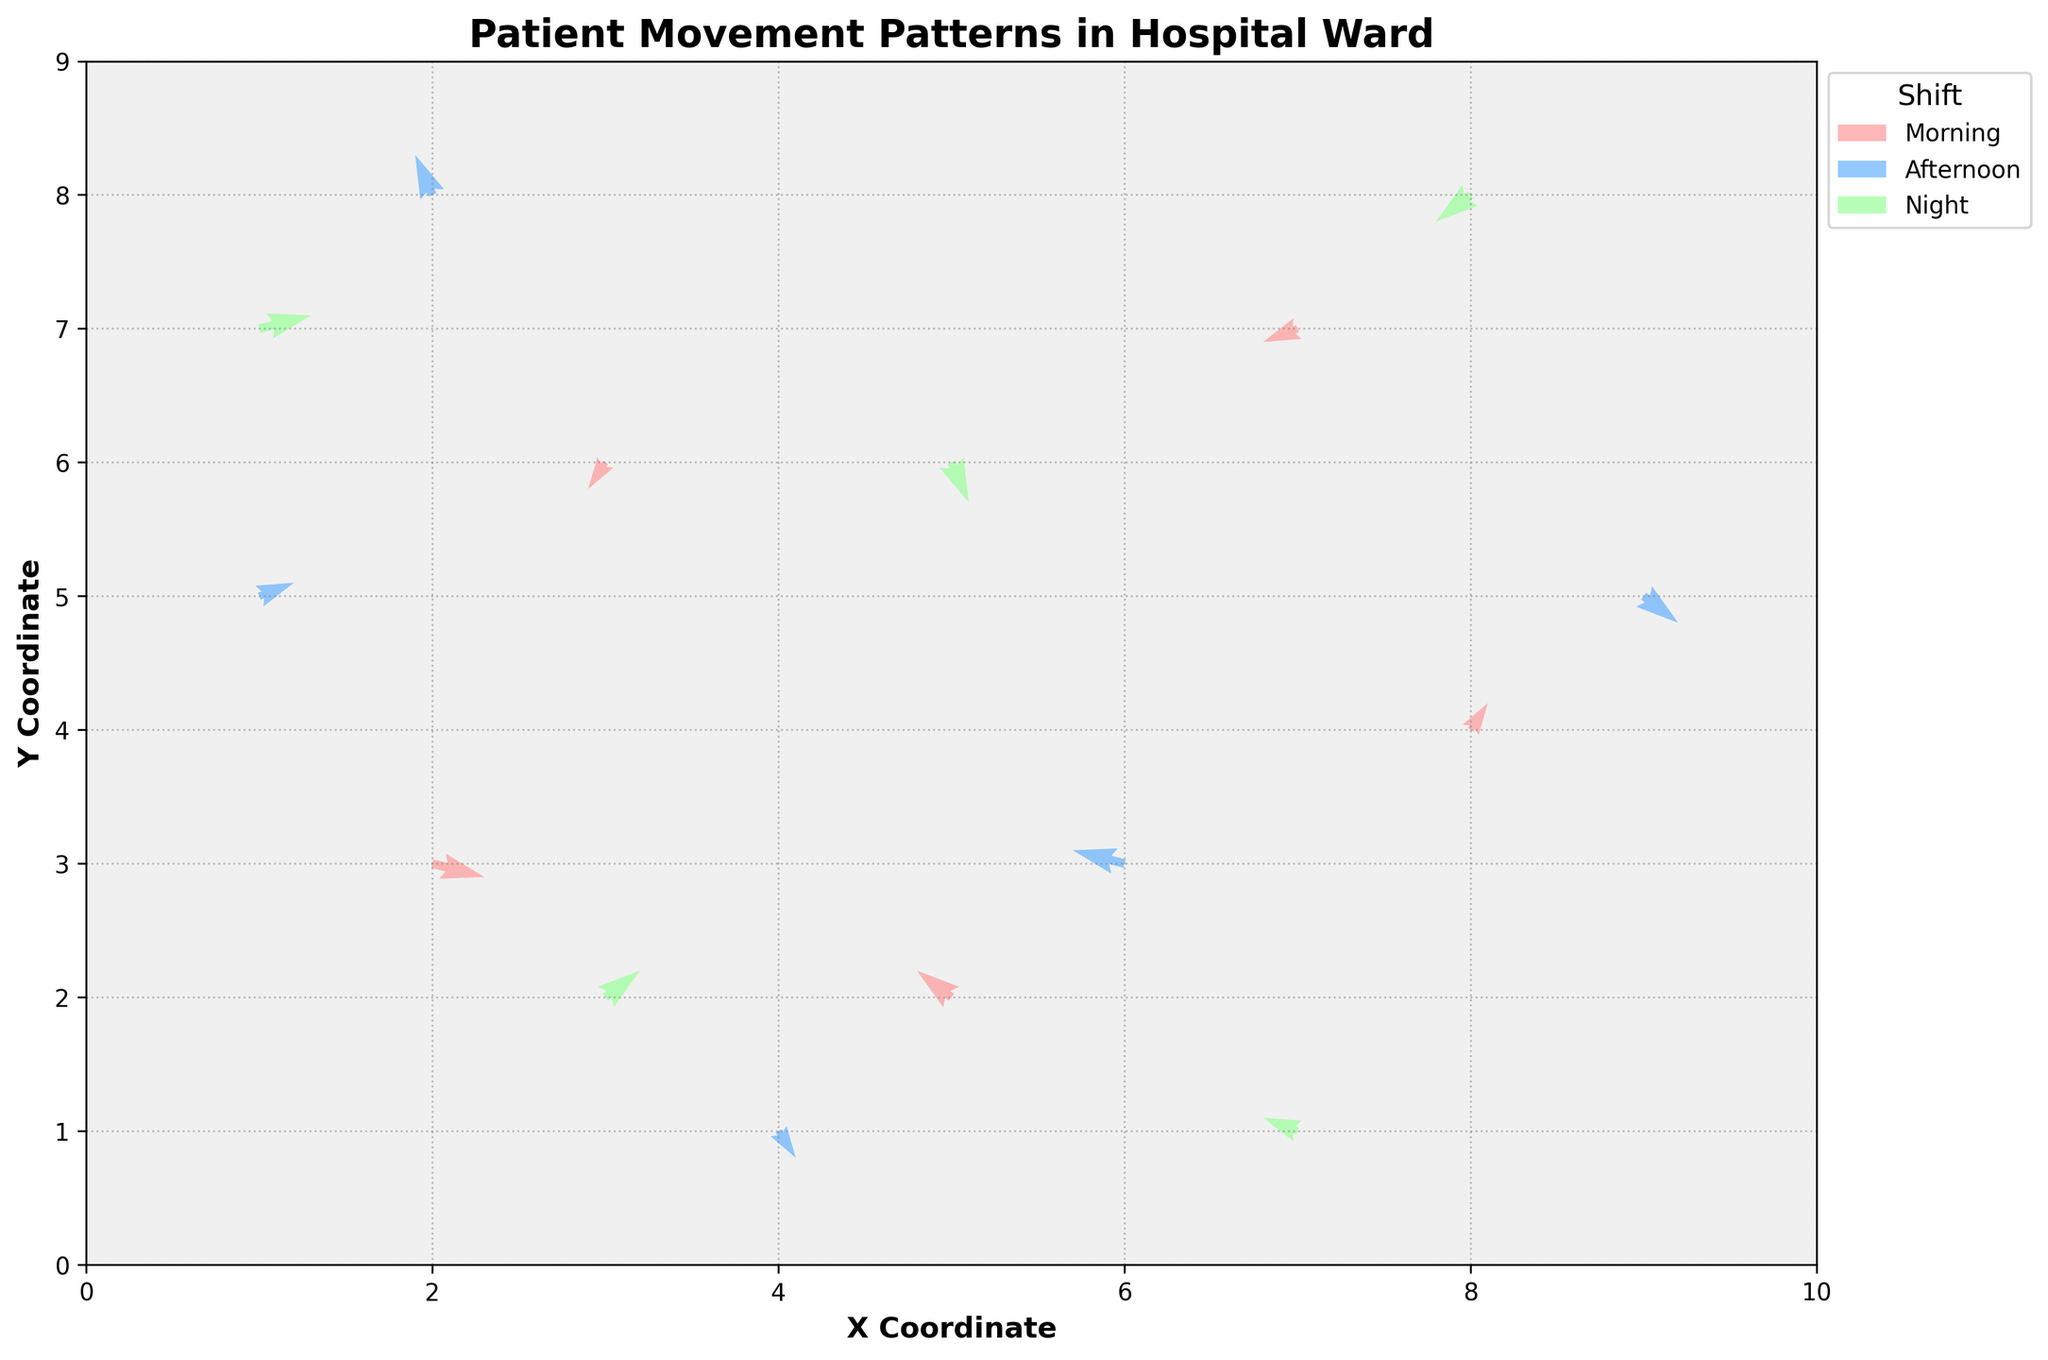What is the title of the plot? The title is seen at the top of the plot and is written in bold.
Answer: Patient Movement Patterns in Hospital Ward How many shifts are represented in the plot? The legend on the right side of the plot lists the different shifts, each with a different color.
Answer: Three shifts What color is used to represent the Afternoon shift? The color associated with each shift is indicated in the legend on the right side.
Answer: Blue What are the x-axis and y-axis labels in the plot? The labels are found along the edges of the plot, horizontally and vertically.
Answer: X Coordinate and Y Coordinate What is the direction of movement for the patient starting at the point (2, 3) in the Morning shift? The arrows in the quiver plot point in the direction of movement. The starting point is (2, 3), and the corresponding arrow points right and slightly down.
Answer: Right and slightly down Which shift shows the largest amount of movement in the positive y-direction? Observing the arrows pointing upward, we'll compare the lengths of upward movements across shifts.
Answer: Afternoon shift How does the movement pattern differ between Morning and Night shifts? By comparing the arrows of both shifts, we can assess overall directions and lengths. Morning shift arrows primarily point in various directions with short lengths, while Night shift arrows often point downward and left.
Answer: Morning shift has varied movements; Night shift has downward and left movements Where does the greatest upward movement occur and in which shift? The longest arrow pointing directly upward on the plot shows the steepest upward movement. This happens at point (2, 8) with a movement of 1.5 units in the y-direction.
Answer: At point (2, 8) in the Afternoon shift How many data points are there per shift? By examining each colored arrow cluster, we count the number of arrows representing each shift. Each shift has 5 arrows.
Answer: 5 data points per shift Which data point shows a movement of 1.5 units up in the Night shift? Arrows pointing up and the length indicate movement magnitude. Examining the Night shift arrows reveals that the data point at (1, 7) has 1.5 units upward.
Answer: At point (1, 7) 